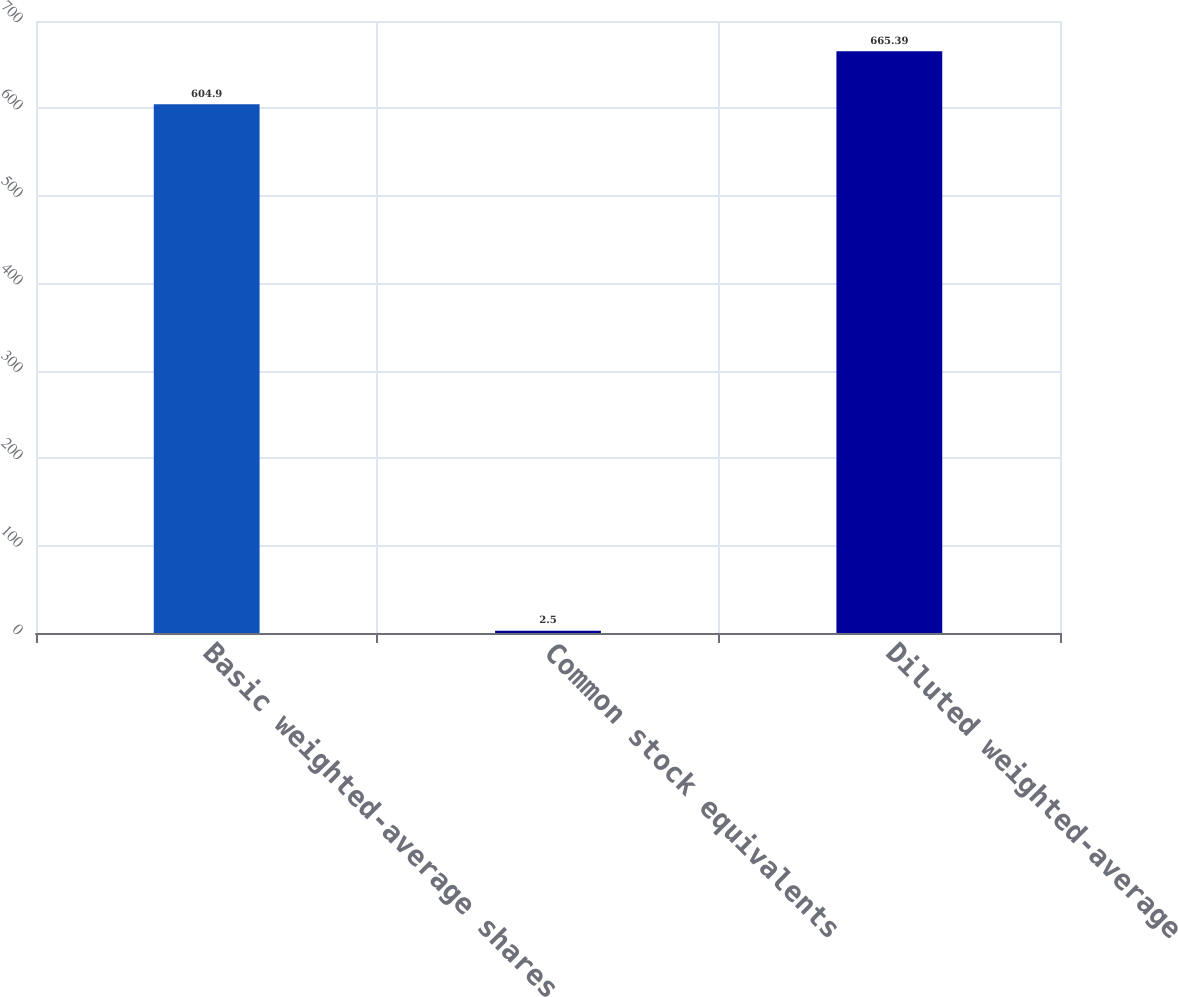Convert chart. <chart><loc_0><loc_0><loc_500><loc_500><bar_chart><fcel>Basic weighted-average shares<fcel>Common stock equivalents<fcel>Diluted weighted-average<nl><fcel>604.9<fcel>2.5<fcel>665.39<nl></chart> 